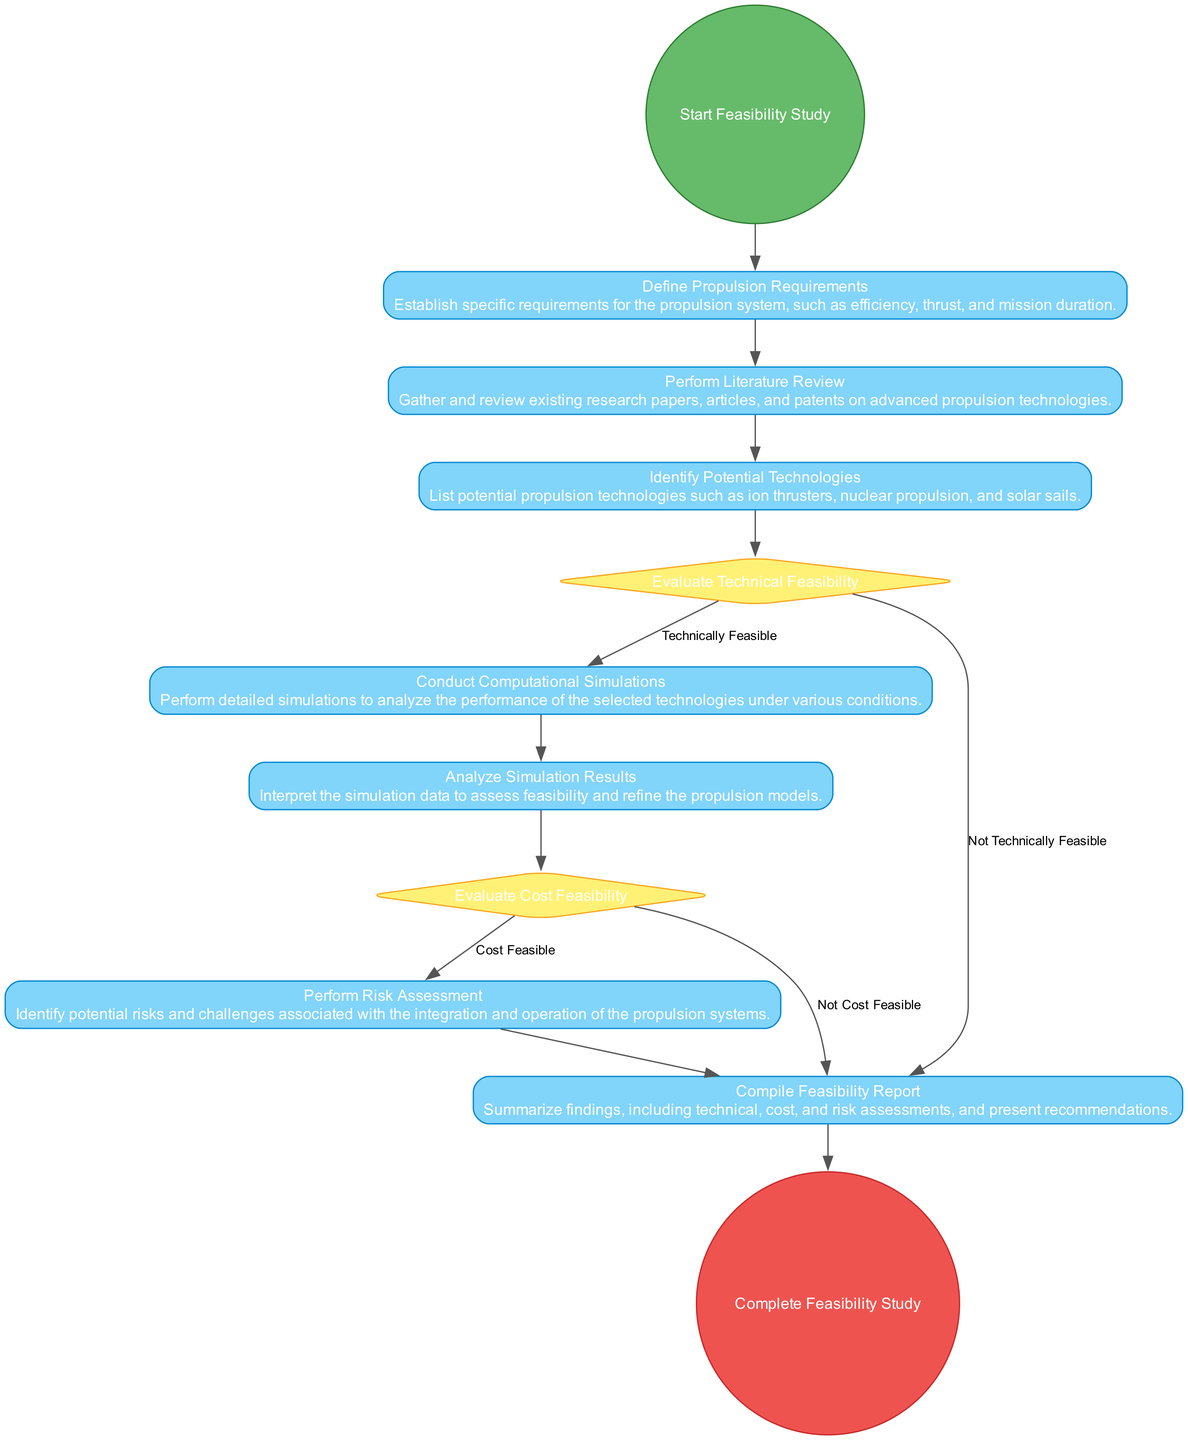What is the starting event of the diagram? The starting event is labeled as "Start Feasibility Study". This is the first node in the activity flow, indicating the initiation of the entire process.
Answer: Start Feasibility Study How many nodes are there in total? Counting all the nodes listed in the diagram (including start, actions, decisions, and end events), there are 11 nodes in total.
Answer: 11 What is the condition for proceeding from "Evaluate Technical Feasibility" to "Conduct Computational Simulations"? The condition that allows for moving from "Evaluate Technical Feasibility" to "Conduct Computational Simulations" is that the technologies being considered must be "Technically Feasible".
Answer: Technically Feasible Which node follows "Analyze Simulation Results"? The node that directly follows "Analyze Simulation Results" in the flow of the activity diagram is "Evaluate Cost Feasibility". This represents the next step after interpreting simulation data.
Answer: Evaluate Cost Feasibility What action occurs after "Perform Risk Assessment"? The action that occurs after "Perform Risk Assessment" is "Compile Feasibility Report". This step involves summarizing findings based on the previous assessments.
Answer: Compile Feasibility Report What are the two possible outcomes after evaluating technical feasibility? The two outcomes are "Conduct Computational Simulations" if the technologies are found to be "Technically Feasible" or "Compile Feasibility Report" if they are "Not Technically Feasible". This indicates a binary decision point in the process flow.
Answer: Conduct Computational Simulations or Compile Feasibility Report What node does the diagram end with? The diagram concludes with the node labeled "Complete Feasibility Study", marking the final point of the process after compiling the feasibility report.
Answer: Complete Feasibility Study Which node involves the estimate of costs associated with propulsion technologies? The node that involves estimating costs is "Evaluate Cost Feasibility". This step is focused on assessing financial aspects related to the propulsion technologies being studied.
Answer: Evaluate Cost Feasibility 